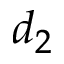Convert formula to latex. <formula><loc_0><loc_0><loc_500><loc_500>d _ { 2 }</formula> 